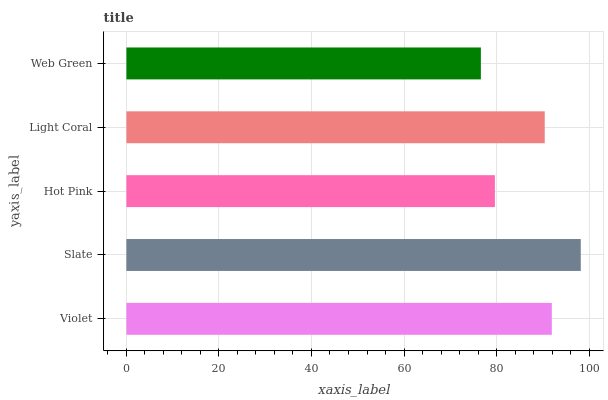Is Web Green the minimum?
Answer yes or no. Yes. Is Slate the maximum?
Answer yes or no. Yes. Is Hot Pink the minimum?
Answer yes or no. No. Is Hot Pink the maximum?
Answer yes or no. No. Is Slate greater than Hot Pink?
Answer yes or no. Yes. Is Hot Pink less than Slate?
Answer yes or no. Yes. Is Hot Pink greater than Slate?
Answer yes or no. No. Is Slate less than Hot Pink?
Answer yes or no. No. Is Light Coral the high median?
Answer yes or no. Yes. Is Light Coral the low median?
Answer yes or no. Yes. Is Web Green the high median?
Answer yes or no. No. Is Violet the low median?
Answer yes or no. No. 